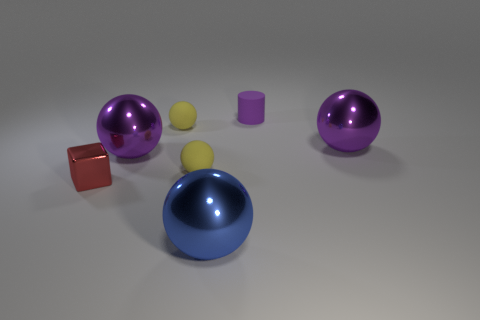There is a metallic ball on the left side of the big blue thing; what is its color?
Your answer should be very brief. Purple. There is a metal ball that is to the right of the blue metal object; does it have the same size as the matte thing that is on the right side of the big blue shiny thing?
Keep it short and to the point. No. Are there any rubber balls of the same size as the rubber cylinder?
Your answer should be compact. Yes. There is a large shiny object that is on the right side of the small purple cylinder; what number of purple things are left of it?
Your answer should be compact. 2. What material is the small red object?
Your response must be concise. Metal. There is a matte cylinder; how many large shiny balls are on the left side of it?
Your answer should be compact. 2. What number of big objects are the same color as the matte cylinder?
Offer a terse response. 2. Are there more brown objects than tiny yellow matte balls?
Provide a succinct answer. No. There is a shiny object that is on the left side of the big blue metallic ball and to the right of the tiny shiny cube; what size is it?
Keep it short and to the point. Large. Is the material of the sphere that is right of the small rubber cylinder the same as the purple object on the left side of the tiny purple rubber cylinder?
Offer a terse response. Yes. 